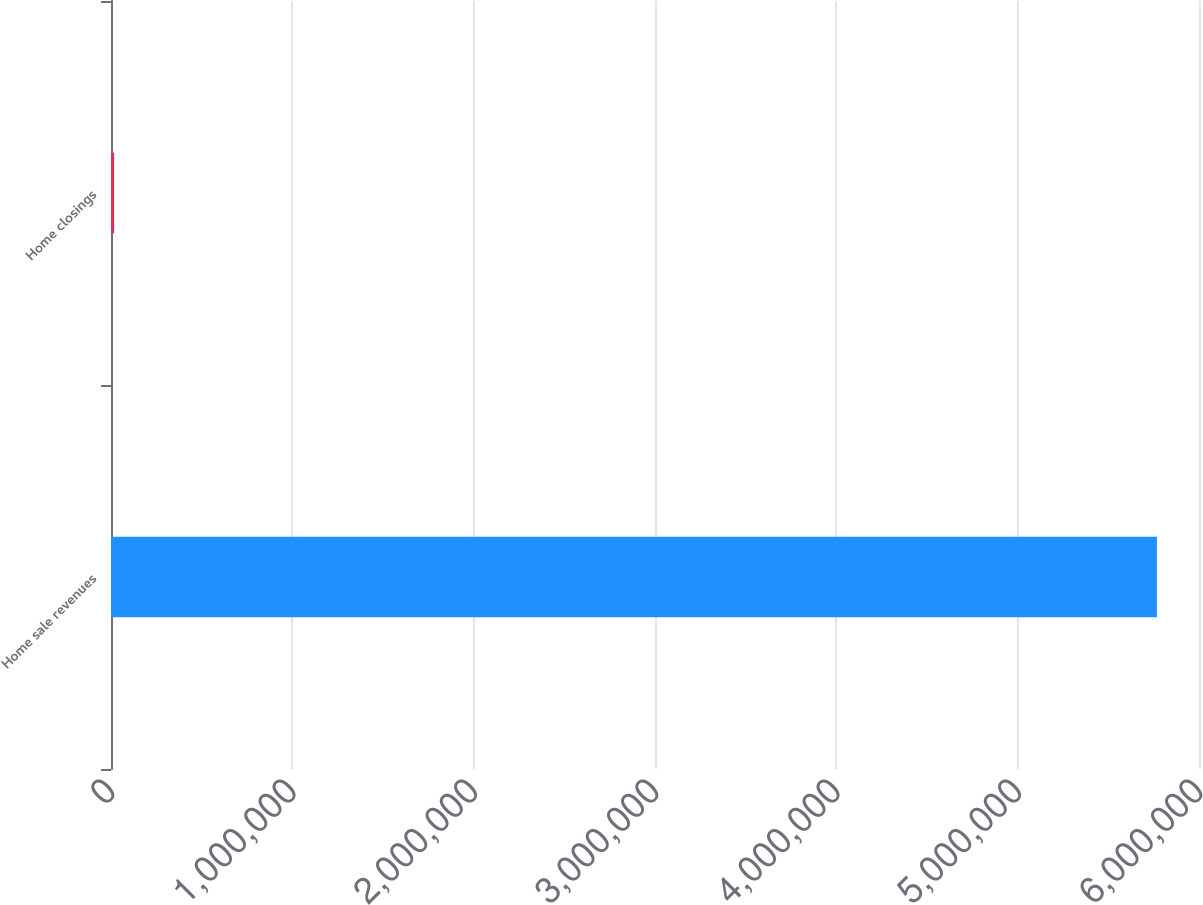<chart> <loc_0><loc_0><loc_500><loc_500><bar_chart><fcel>Home sale revenues<fcel>Home closings<nl><fcel>5.79268e+06<fcel>17127<nl></chart> 